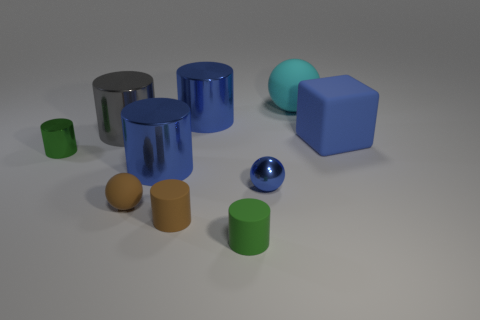What number of other things are the same color as the rubber cube?
Provide a succinct answer. 3. The big blue metallic object in front of the tiny cylinder behind the blue metallic cylinder that is in front of the big blue cube is what shape?
Your answer should be compact. Cylinder. Does the small metal cylinder have the same color as the tiny matte ball?
Ensure brevity in your answer.  No. Are there more cyan spheres than purple spheres?
Provide a short and direct response. Yes. What number of other things are there of the same material as the small brown cylinder
Provide a succinct answer. 4. What number of objects are either tiny brown balls or tiny green cylinders that are left of the green matte cylinder?
Your answer should be very brief. 2. Is the number of tiny rubber balls less than the number of gray rubber objects?
Offer a terse response. No. What color is the tiny shiny cylinder in front of the blue cylinder that is right of the big blue metallic cylinder that is in front of the large block?
Your answer should be very brief. Green. Is the material of the brown sphere the same as the cyan object?
Offer a terse response. Yes. How many brown cylinders are behind the large gray cylinder?
Give a very brief answer. 0. 